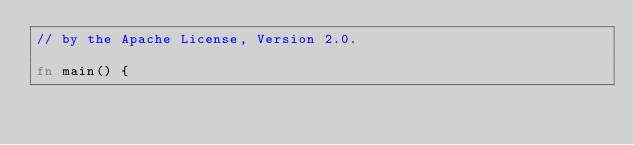Convert code to text. <code><loc_0><loc_0><loc_500><loc_500><_Rust_>// by the Apache License, Version 2.0.

fn main() {</code> 